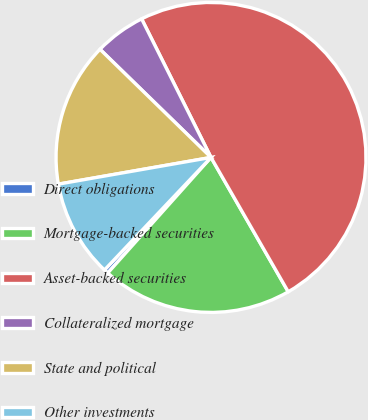<chart> <loc_0><loc_0><loc_500><loc_500><pie_chart><fcel>Direct obligations<fcel>Mortgage-backed securities<fcel>Asset-backed securities<fcel>Collateralized mortgage<fcel>State and political<fcel>Other investments<nl><fcel>0.46%<fcel>19.91%<fcel>49.09%<fcel>5.32%<fcel>15.05%<fcel>10.18%<nl></chart> 